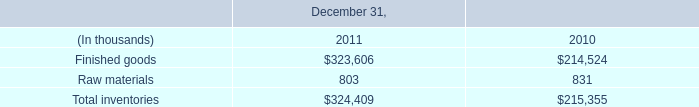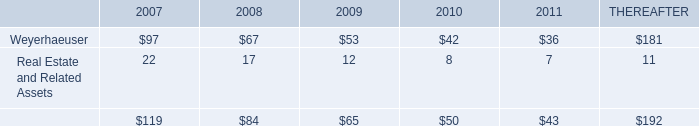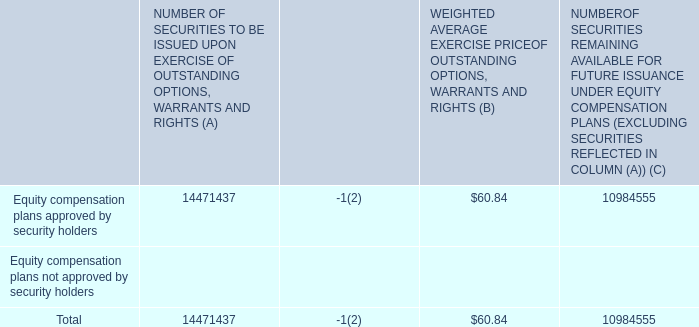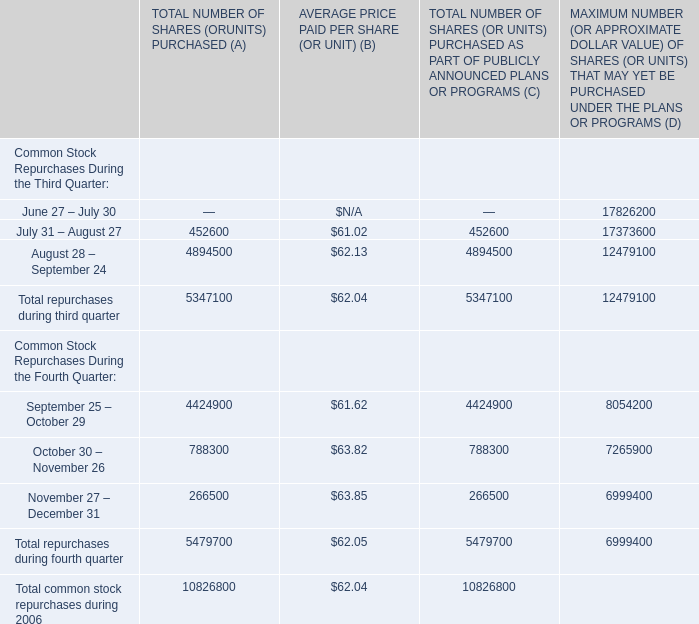What is the value of the WEIGHTED AVERAGE EXERCISE PRICE OF OUTSTANDING OPTIONS, WARRANTS AND RIGHTS (B) for Total? 
Answer: 60.84. 